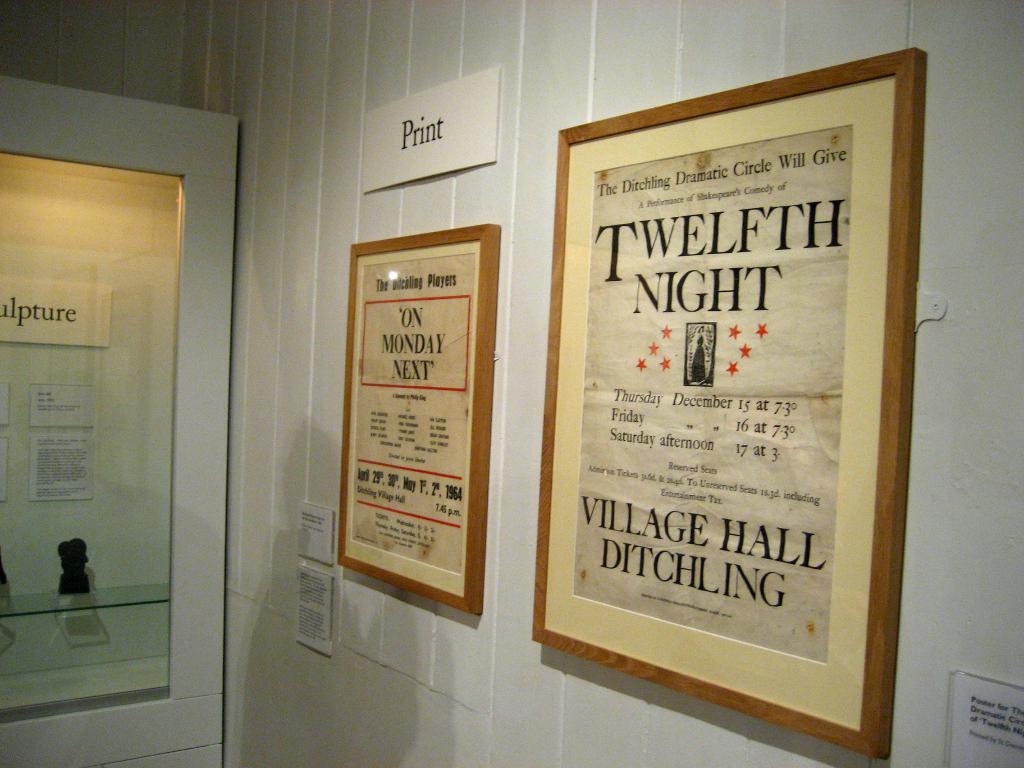What night is it according to the old paper farthest to the right?
Provide a short and direct response. Twelfth. What is the last word written in large text on the paper on the right?
Your answer should be very brief. Ditchling. 